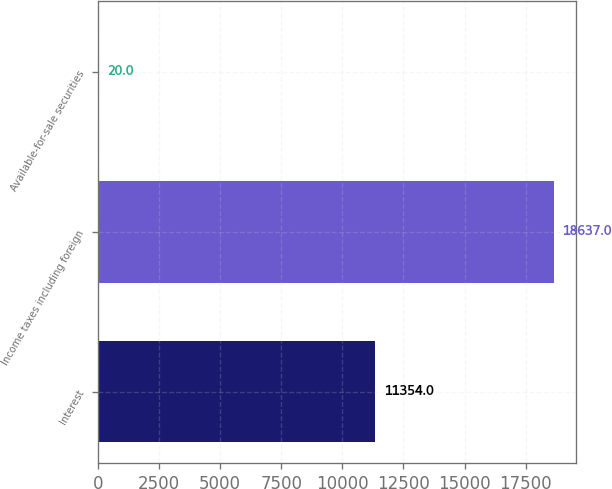<chart> <loc_0><loc_0><loc_500><loc_500><bar_chart><fcel>Interest<fcel>Income taxes including foreign<fcel>Available-for-sale securities<nl><fcel>11354<fcel>18637<fcel>20<nl></chart> 